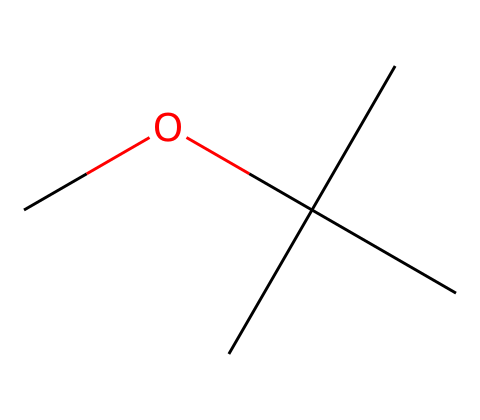What is the molecular formula of MTBE? To determine the molecular formula, we can analyze the SMILES representation. The "C" represents carbon atoms, and the "O" represents oxygen. Counting the "C" atoms (4 from the tert-butyl group and 1 from the ether bond) gives us 5 carbons (C5). There are 12 hydrogen atoms (based on tetravalency of carbon and the structure of the molecule) and 1 oxygen atom. Thus, the molecular formula is C5H12O.
Answer: C5H12O How many carbon atoms are in the structure of MTBE? By examining the SMILES representation, we see that there are five "C" characters, which represent carbon atoms in the molecule. Therefore, the total number of carbon atoms is five.
Answer: 5 Is this compound classified as a primary, secondary, or tertiary ether? The ether in MTBE features a branching tert-butyl group, which is characteristic of tertiary ethers. The central carbon in tert-butyl is bonded to three other carbon atoms. Thus, we classify MTBE as a tertiary ether.
Answer: tertiary ether What type of functional group does MTBE contain? The presence of the "O" bonded to two carbon chains (the alkyl groups in this case) indicates that MTBE contains an ether functional group, which is defined by this specific arrangement of atoms.
Answer: ether What is the total number of hydrogen atoms in MTBE? In the chemical structure, each carbon typically bonds with up to four other atoms. Considering the structure and accounting for the bonds to the oxygen and the branching, we find there are 12 hydrogen atoms in total.
Answer: 12 What impact does MTBE have on air quality when used in gasoline? MTBE is associated with potential air quality issues due to its volatility and tendency to produce ozone when burnt, which can lead to smog and respiratory problems. As a result, its use as a fuel additive is closely monitored and regulated to mitigate environmental issues.
Answer: ozone 